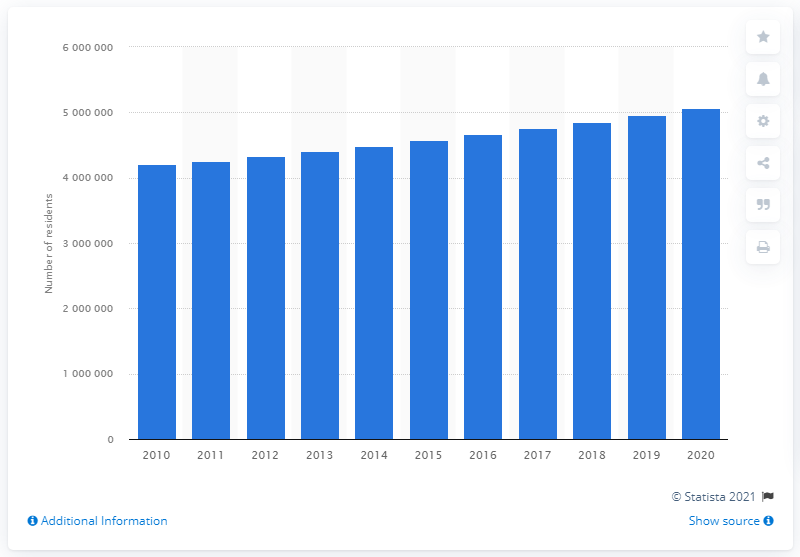List a handful of essential elements in this visual. The population of Phoenix-Mesa-Chandler in the previous year was 495,3901. In the year 2020, the population of the Phoenix-Mesa-Chandler metropolitan area was approximately 5059909. 